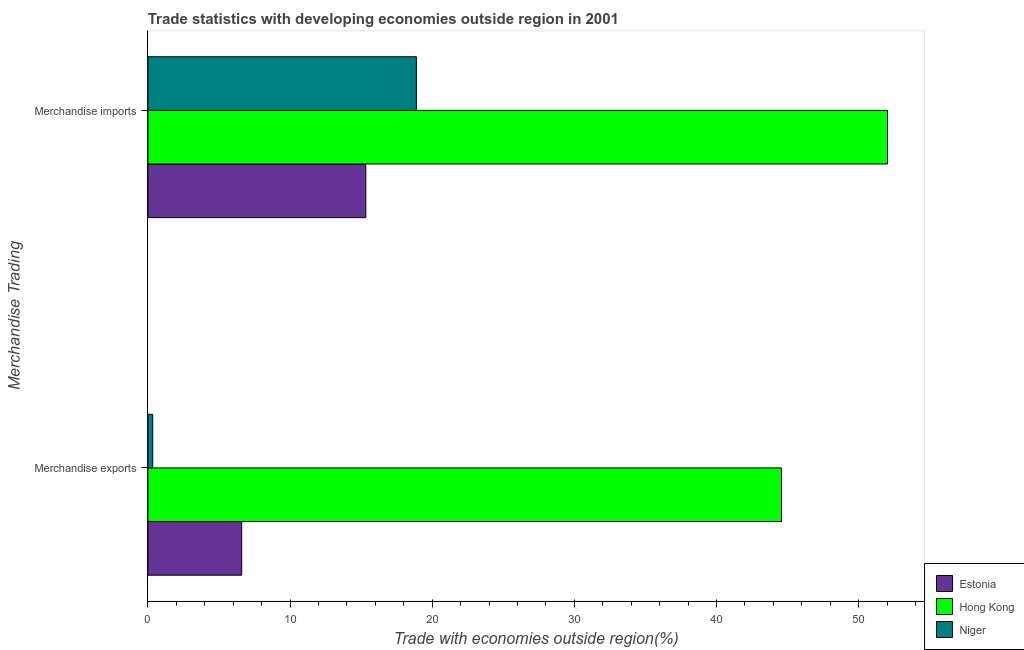How many different coloured bars are there?
Provide a succinct answer. 3. How many groups of bars are there?
Offer a very short reply. 2. Are the number of bars per tick equal to the number of legend labels?
Offer a terse response. Yes. Are the number of bars on each tick of the Y-axis equal?
Make the answer very short. Yes. How many bars are there on the 2nd tick from the top?
Keep it short and to the point. 3. How many bars are there on the 1st tick from the bottom?
Your answer should be very brief. 3. What is the merchandise exports in Niger?
Provide a succinct answer. 0.34. Across all countries, what is the maximum merchandise exports?
Offer a terse response. 44.58. Across all countries, what is the minimum merchandise imports?
Offer a terse response. 15.33. In which country was the merchandise imports maximum?
Keep it short and to the point. Hong Kong. In which country was the merchandise exports minimum?
Offer a very short reply. Niger. What is the total merchandise imports in the graph?
Offer a very short reply. 86.26. What is the difference between the merchandise imports in Estonia and that in Niger?
Keep it short and to the point. -3.56. What is the difference between the merchandise exports in Estonia and the merchandise imports in Niger?
Keep it short and to the point. -12.29. What is the average merchandise exports per country?
Offer a terse response. 17.17. What is the difference between the merchandise imports and merchandise exports in Niger?
Give a very brief answer. 18.55. What is the ratio of the merchandise exports in Hong Kong to that in Niger?
Your answer should be very brief. 130.76. Is the merchandise imports in Estonia less than that in Niger?
Make the answer very short. Yes. In how many countries, is the merchandise imports greater than the average merchandise imports taken over all countries?
Keep it short and to the point. 1. What does the 3rd bar from the top in Merchandise imports represents?
Make the answer very short. Estonia. What does the 1st bar from the bottom in Merchandise imports represents?
Your answer should be compact. Estonia. How many countries are there in the graph?
Make the answer very short. 3. What is the difference between two consecutive major ticks on the X-axis?
Provide a succinct answer. 10. How many legend labels are there?
Your response must be concise. 3. How are the legend labels stacked?
Make the answer very short. Vertical. What is the title of the graph?
Offer a very short reply. Trade statistics with developing economies outside region in 2001. What is the label or title of the X-axis?
Your response must be concise. Trade with economies outside region(%). What is the label or title of the Y-axis?
Your response must be concise. Merchandise Trading. What is the Trade with economies outside region(%) of Estonia in Merchandise exports?
Provide a short and direct response. 6.6. What is the Trade with economies outside region(%) of Hong Kong in Merchandise exports?
Give a very brief answer. 44.58. What is the Trade with economies outside region(%) in Niger in Merchandise exports?
Keep it short and to the point. 0.34. What is the Trade with economies outside region(%) of Estonia in Merchandise imports?
Your response must be concise. 15.33. What is the Trade with economies outside region(%) of Hong Kong in Merchandise imports?
Offer a terse response. 52.04. What is the Trade with economies outside region(%) of Niger in Merchandise imports?
Provide a short and direct response. 18.89. Across all Merchandise Trading, what is the maximum Trade with economies outside region(%) of Estonia?
Provide a succinct answer. 15.33. Across all Merchandise Trading, what is the maximum Trade with economies outside region(%) of Hong Kong?
Make the answer very short. 52.04. Across all Merchandise Trading, what is the maximum Trade with economies outside region(%) in Niger?
Provide a short and direct response. 18.89. Across all Merchandise Trading, what is the minimum Trade with economies outside region(%) of Estonia?
Your answer should be compact. 6.6. Across all Merchandise Trading, what is the minimum Trade with economies outside region(%) of Hong Kong?
Offer a terse response. 44.58. Across all Merchandise Trading, what is the minimum Trade with economies outside region(%) in Niger?
Provide a short and direct response. 0.34. What is the total Trade with economies outside region(%) of Estonia in the graph?
Offer a terse response. 21.93. What is the total Trade with economies outside region(%) of Hong Kong in the graph?
Give a very brief answer. 96.61. What is the total Trade with economies outside region(%) of Niger in the graph?
Your answer should be compact. 19.23. What is the difference between the Trade with economies outside region(%) of Estonia in Merchandise exports and that in Merchandise imports?
Provide a short and direct response. -8.73. What is the difference between the Trade with economies outside region(%) of Hong Kong in Merchandise exports and that in Merchandise imports?
Make the answer very short. -7.46. What is the difference between the Trade with economies outside region(%) in Niger in Merchandise exports and that in Merchandise imports?
Your answer should be compact. -18.55. What is the difference between the Trade with economies outside region(%) of Estonia in Merchandise exports and the Trade with economies outside region(%) of Hong Kong in Merchandise imports?
Offer a very short reply. -45.44. What is the difference between the Trade with economies outside region(%) in Estonia in Merchandise exports and the Trade with economies outside region(%) in Niger in Merchandise imports?
Ensure brevity in your answer.  -12.29. What is the difference between the Trade with economies outside region(%) in Hong Kong in Merchandise exports and the Trade with economies outside region(%) in Niger in Merchandise imports?
Provide a short and direct response. 25.68. What is the average Trade with economies outside region(%) of Estonia per Merchandise Trading?
Your answer should be very brief. 10.97. What is the average Trade with economies outside region(%) in Hong Kong per Merchandise Trading?
Provide a succinct answer. 48.31. What is the average Trade with economies outside region(%) in Niger per Merchandise Trading?
Keep it short and to the point. 9.62. What is the difference between the Trade with economies outside region(%) in Estonia and Trade with economies outside region(%) in Hong Kong in Merchandise exports?
Your answer should be very brief. -37.97. What is the difference between the Trade with economies outside region(%) of Estonia and Trade with economies outside region(%) of Niger in Merchandise exports?
Make the answer very short. 6.26. What is the difference between the Trade with economies outside region(%) of Hong Kong and Trade with economies outside region(%) of Niger in Merchandise exports?
Give a very brief answer. 44.23. What is the difference between the Trade with economies outside region(%) of Estonia and Trade with economies outside region(%) of Hong Kong in Merchandise imports?
Provide a short and direct response. -36.7. What is the difference between the Trade with economies outside region(%) of Estonia and Trade with economies outside region(%) of Niger in Merchandise imports?
Give a very brief answer. -3.56. What is the difference between the Trade with economies outside region(%) in Hong Kong and Trade with economies outside region(%) in Niger in Merchandise imports?
Provide a succinct answer. 33.15. What is the ratio of the Trade with economies outside region(%) of Estonia in Merchandise exports to that in Merchandise imports?
Make the answer very short. 0.43. What is the ratio of the Trade with economies outside region(%) of Hong Kong in Merchandise exports to that in Merchandise imports?
Your answer should be compact. 0.86. What is the ratio of the Trade with economies outside region(%) in Niger in Merchandise exports to that in Merchandise imports?
Give a very brief answer. 0.02. What is the difference between the highest and the second highest Trade with economies outside region(%) of Estonia?
Your response must be concise. 8.73. What is the difference between the highest and the second highest Trade with economies outside region(%) in Hong Kong?
Your answer should be compact. 7.46. What is the difference between the highest and the second highest Trade with economies outside region(%) in Niger?
Give a very brief answer. 18.55. What is the difference between the highest and the lowest Trade with economies outside region(%) in Estonia?
Your answer should be very brief. 8.73. What is the difference between the highest and the lowest Trade with economies outside region(%) in Hong Kong?
Ensure brevity in your answer.  7.46. What is the difference between the highest and the lowest Trade with economies outside region(%) in Niger?
Ensure brevity in your answer.  18.55. 